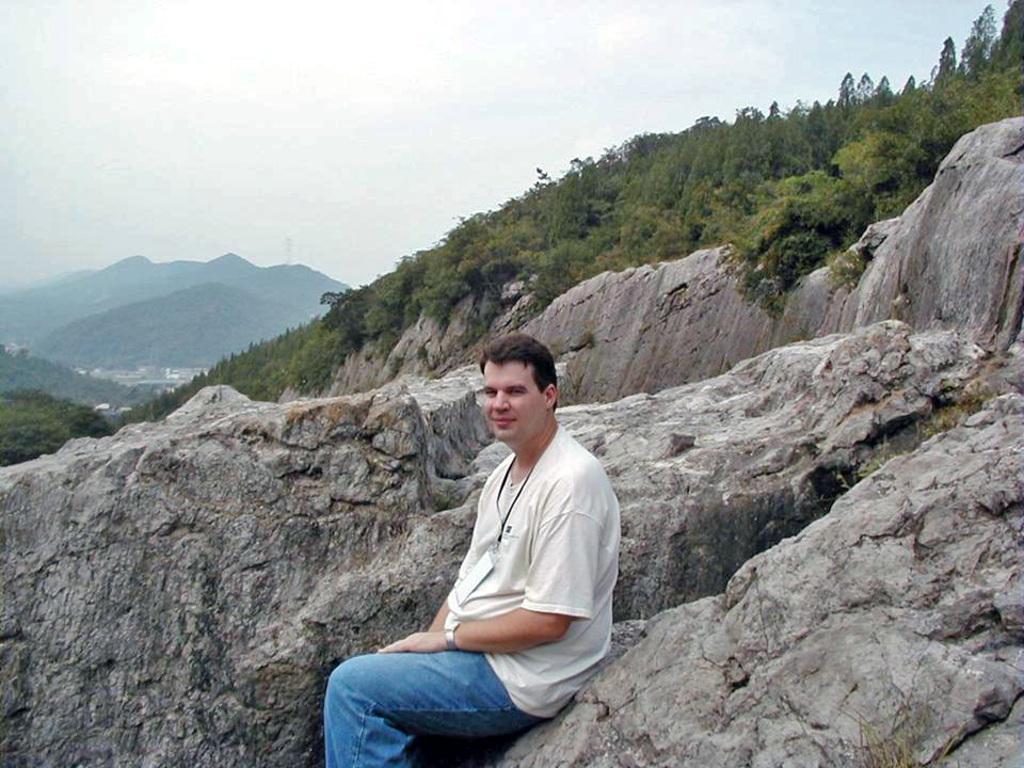Please provide a concise description of this image. In the center of the picture there is a person sitting on the rock. In the center there are trees and hills. Sky is cloudy. 